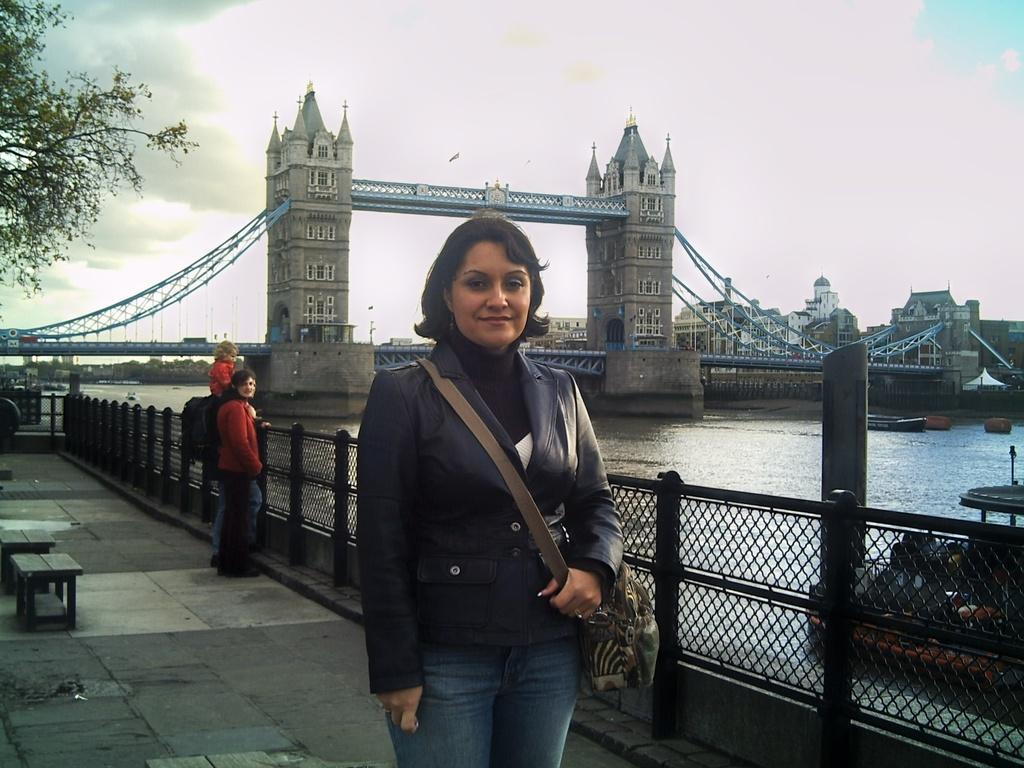In one or two sentences, can you explain what this image depicts? In this image there is a woman carrying a bag. She is standing on the floor having few benches. Few people are standing near the fence. There is a bridge in the middle of the image. Behind there are buildings and trees. Right side there is a boat in the water. Left side there are trees. Top of the image there is sky. 